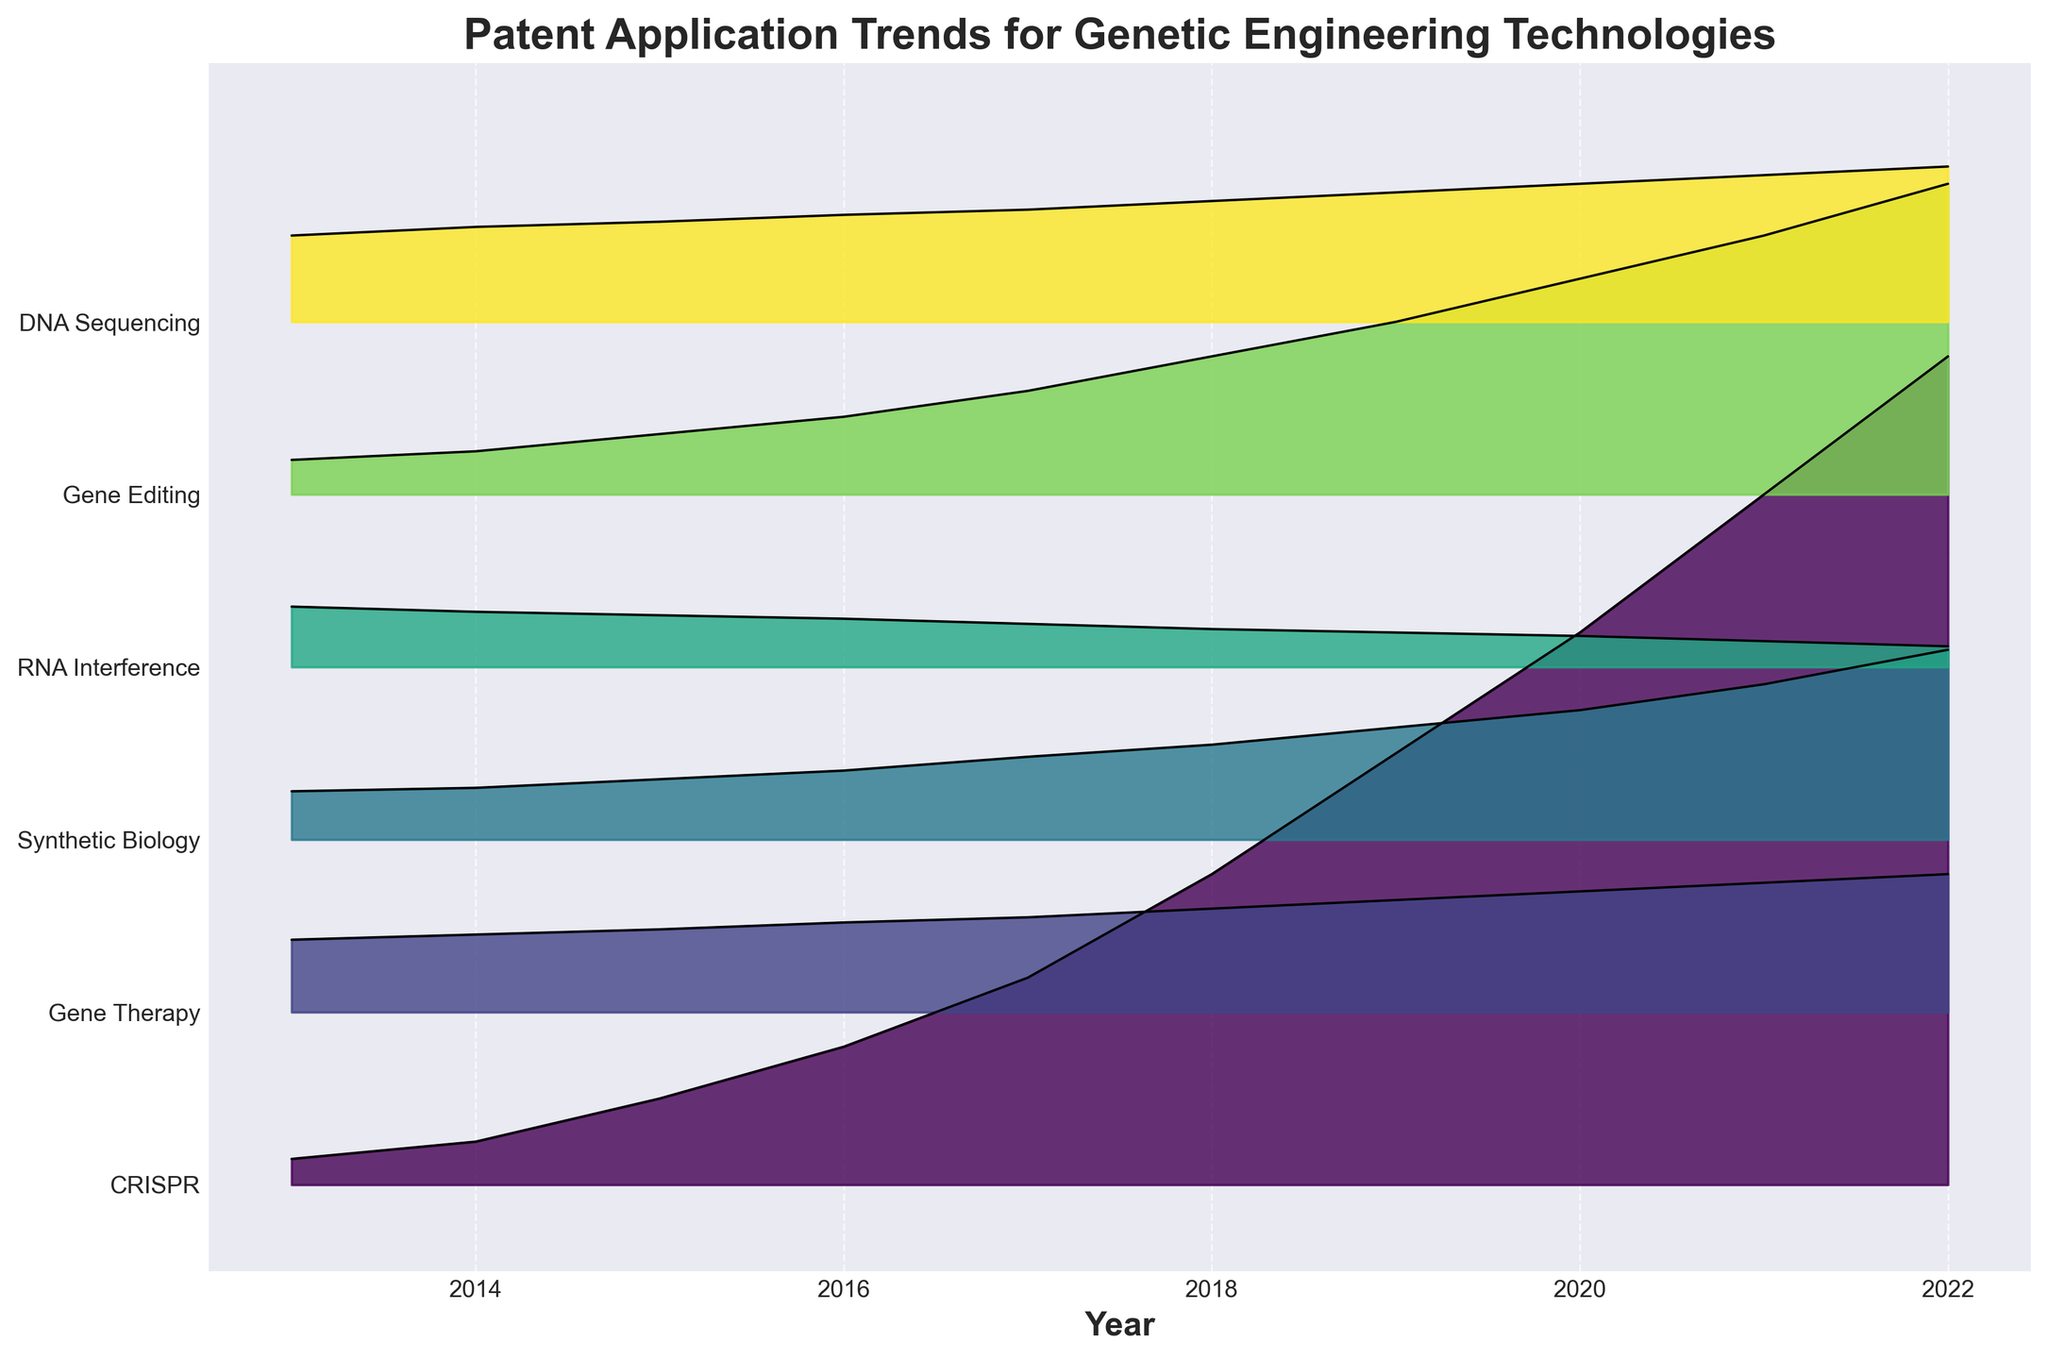What's the title of the figure? The title is written at the top of the plot. It reads "Patent Application Trends for Genetic Engineering Technologies".
Answer: Patent Application Trends for Genetic Engineering Technologies How many genetic engineering technologies are compared in the plot? Count the number of fill areas in different colors, each representing a different technology. There are six distinct fill areas.
Answer: Six Which genetic engineering technology had the highest number of patent applications in 2022? Look at the topmost line in the year 2022. CRISPR clearly has the highest peak at that year.
Answer: CRISPR Between which two consecutive years did CRISPR see the largest increase in patent applications? Observe the distance between each yearly increase for CRISPR. The largest jump is between 2019 and 2020.
Answer: 2019 and 2020 What is the overall trend of patent applications for RNA Interference over the decade? Identify the fill area for RNA Interference and observe its trend from 2013 to 2022. The area decreases gradually over the years.
Answer: Decreasing In 2020, how many more patent applications did DNA Sequencing have compared to Synthetic Biology? Identify the positions of DNA Sequencing and Synthetic Biology in 2020 and read their values. DNA Sequencing is at 80, Synthetic Biology is at 75. The difference is 80 - 75.
Answer: 5 Which genetic engineering technology showed the fastest growth in patent applications from 2017 to 2019? Compare the slopes of each technology's fill area between 2017 and 2019. CRISPR has the steepest slope indicating the fastest growth.
Answer: CRISPR How did the number of patent applications for Gene Editing change from 2013 to 2022? Notice the starting and ending points of the Gene Editing fill area from 2013 to 2022. It starts at 20 in 2013 and ends at 180 in 2022, indicating an increase.
Answer: Increased What is the range of patent applications for Gene Therapy over the years? Identify the highest and lowest points of the Gene Therapy fill area. The lowest is 42 in 2013 and the highest is 80 in 2022. The range is 80 - 42.
Answer: 38 How did Synthetic Biology trends differ between the first and the last quarter of the decade? Compare the fill area for Synthetic Biology from 2013-2018 (first half) and from 2018-2022 (second half). The area shows moderate increase in the first half and rapid increase in the second half.
Answer: Moderate increase then rapid increase 